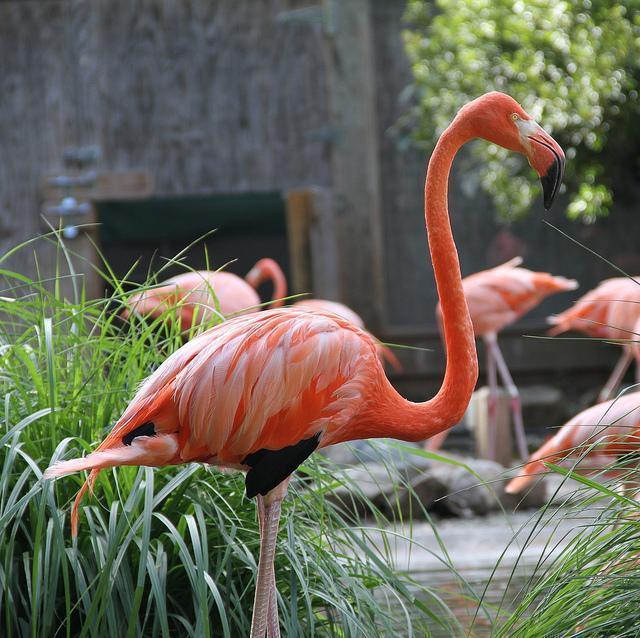How many birds are in focus?
Select the accurate response from the four choices given to answer the question.
Options: Four, two, one, three. One. 